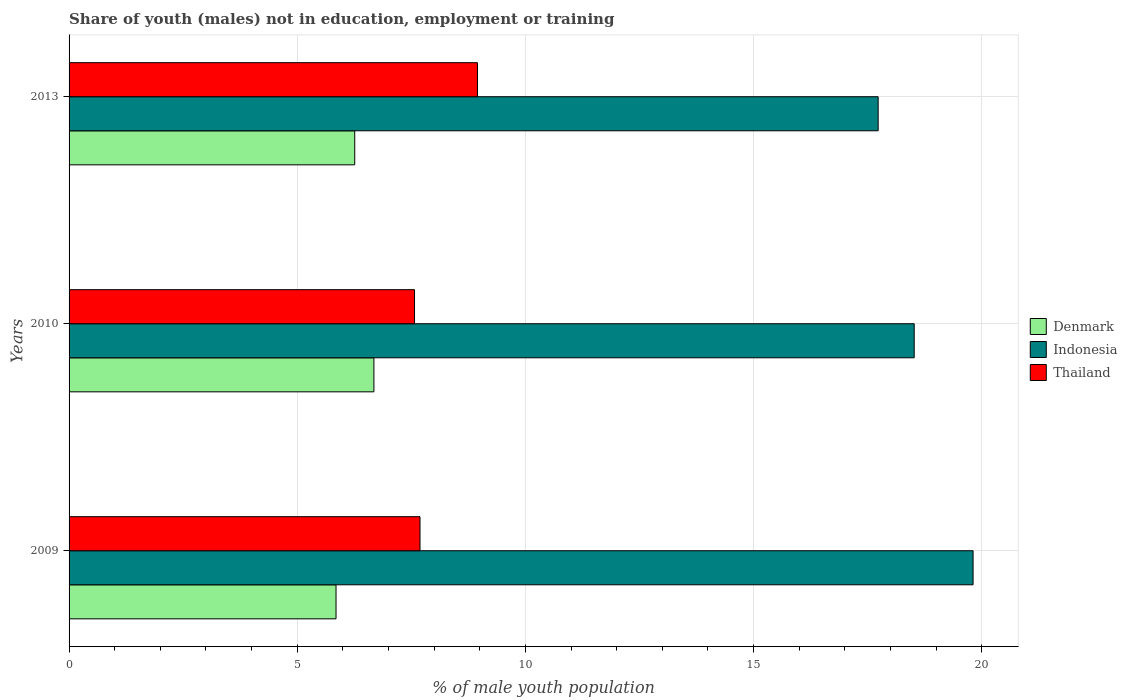How many groups of bars are there?
Keep it short and to the point. 3. Are the number of bars on each tick of the Y-axis equal?
Ensure brevity in your answer.  Yes. What is the label of the 1st group of bars from the top?
Your answer should be compact. 2013. In how many cases, is the number of bars for a given year not equal to the number of legend labels?
Your response must be concise. 0. What is the percentage of unemployed males population in in Indonesia in 2009?
Offer a very short reply. 19.81. Across all years, what is the maximum percentage of unemployed males population in in Indonesia?
Give a very brief answer. 19.81. Across all years, what is the minimum percentage of unemployed males population in in Indonesia?
Keep it short and to the point. 17.73. In which year was the percentage of unemployed males population in in Indonesia maximum?
Ensure brevity in your answer.  2009. What is the total percentage of unemployed males population in in Thailand in the graph?
Provide a short and direct response. 24.21. What is the difference between the percentage of unemployed males population in in Indonesia in 2009 and that in 2010?
Your response must be concise. 1.29. What is the difference between the percentage of unemployed males population in in Indonesia in 2010 and the percentage of unemployed males population in in Thailand in 2013?
Your answer should be very brief. 9.57. What is the average percentage of unemployed males population in in Thailand per year?
Your answer should be compact. 8.07. In the year 2013, what is the difference between the percentage of unemployed males population in in Thailand and percentage of unemployed males population in in Denmark?
Your answer should be very brief. 2.69. What is the ratio of the percentage of unemployed males population in in Indonesia in 2010 to that in 2013?
Make the answer very short. 1.04. Is the percentage of unemployed males population in in Denmark in 2010 less than that in 2013?
Make the answer very short. No. Is the difference between the percentage of unemployed males population in in Thailand in 2009 and 2010 greater than the difference between the percentage of unemployed males population in in Denmark in 2009 and 2010?
Give a very brief answer. Yes. What is the difference between the highest and the second highest percentage of unemployed males population in in Indonesia?
Provide a succinct answer. 1.29. What is the difference between the highest and the lowest percentage of unemployed males population in in Indonesia?
Make the answer very short. 2.08. Is the sum of the percentage of unemployed males population in in Indonesia in 2010 and 2013 greater than the maximum percentage of unemployed males population in in Thailand across all years?
Your answer should be compact. Yes. What does the 3rd bar from the top in 2013 represents?
Your response must be concise. Denmark. How many bars are there?
Ensure brevity in your answer.  9. How many years are there in the graph?
Offer a very short reply. 3. What is the difference between two consecutive major ticks on the X-axis?
Keep it short and to the point. 5. Does the graph contain grids?
Make the answer very short. Yes. What is the title of the graph?
Provide a short and direct response. Share of youth (males) not in education, employment or training. Does "Iran" appear as one of the legend labels in the graph?
Offer a terse response. No. What is the label or title of the X-axis?
Your answer should be compact. % of male youth population. What is the % of male youth population of Denmark in 2009?
Your response must be concise. 5.85. What is the % of male youth population of Indonesia in 2009?
Make the answer very short. 19.81. What is the % of male youth population in Thailand in 2009?
Offer a terse response. 7.69. What is the % of male youth population in Denmark in 2010?
Your answer should be very brief. 6.68. What is the % of male youth population of Indonesia in 2010?
Keep it short and to the point. 18.52. What is the % of male youth population in Thailand in 2010?
Your answer should be compact. 7.57. What is the % of male youth population in Denmark in 2013?
Provide a succinct answer. 6.26. What is the % of male youth population of Indonesia in 2013?
Offer a terse response. 17.73. What is the % of male youth population of Thailand in 2013?
Your answer should be compact. 8.95. Across all years, what is the maximum % of male youth population of Denmark?
Keep it short and to the point. 6.68. Across all years, what is the maximum % of male youth population of Indonesia?
Offer a very short reply. 19.81. Across all years, what is the maximum % of male youth population in Thailand?
Provide a short and direct response. 8.95. Across all years, what is the minimum % of male youth population of Denmark?
Offer a very short reply. 5.85. Across all years, what is the minimum % of male youth population in Indonesia?
Offer a very short reply. 17.73. Across all years, what is the minimum % of male youth population in Thailand?
Provide a succinct answer. 7.57. What is the total % of male youth population in Denmark in the graph?
Your answer should be compact. 18.79. What is the total % of male youth population of Indonesia in the graph?
Provide a short and direct response. 56.06. What is the total % of male youth population in Thailand in the graph?
Keep it short and to the point. 24.21. What is the difference between the % of male youth population in Denmark in 2009 and that in 2010?
Your response must be concise. -0.83. What is the difference between the % of male youth population in Indonesia in 2009 and that in 2010?
Keep it short and to the point. 1.29. What is the difference between the % of male youth population in Thailand in 2009 and that in 2010?
Ensure brevity in your answer.  0.12. What is the difference between the % of male youth population in Denmark in 2009 and that in 2013?
Offer a terse response. -0.41. What is the difference between the % of male youth population in Indonesia in 2009 and that in 2013?
Offer a very short reply. 2.08. What is the difference between the % of male youth population of Thailand in 2009 and that in 2013?
Your answer should be very brief. -1.26. What is the difference between the % of male youth population in Denmark in 2010 and that in 2013?
Your answer should be compact. 0.42. What is the difference between the % of male youth population of Indonesia in 2010 and that in 2013?
Make the answer very short. 0.79. What is the difference between the % of male youth population of Thailand in 2010 and that in 2013?
Give a very brief answer. -1.38. What is the difference between the % of male youth population of Denmark in 2009 and the % of male youth population of Indonesia in 2010?
Provide a short and direct response. -12.67. What is the difference between the % of male youth population of Denmark in 2009 and the % of male youth population of Thailand in 2010?
Ensure brevity in your answer.  -1.72. What is the difference between the % of male youth population of Indonesia in 2009 and the % of male youth population of Thailand in 2010?
Your answer should be compact. 12.24. What is the difference between the % of male youth population of Denmark in 2009 and the % of male youth population of Indonesia in 2013?
Offer a very short reply. -11.88. What is the difference between the % of male youth population in Indonesia in 2009 and the % of male youth population in Thailand in 2013?
Your answer should be compact. 10.86. What is the difference between the % of male youth population in Denmark in 2010 and the % of male youth population in Indonesia in 2013?
Give a very brief answer. -11.05. What is the difference between the % of male youth population in Denmark in 2010 and the % of male youth population in Thailand in 2013?
Keep it short and to the point. -2.27. What is the difference between the % of male youth population in Indonesia in 2010 and the % of male youth population in Thailand in 2013?
Offer a terse response. 9.57. What is the average % of male youth population of Denmark per year?
Give a very brief answer. 6.26. What is the average % of male youth population in Indonesia per year?
Ensure brevity in your answer.  18.69. What is the average % of male youth population in Thailand per year?
Provide a short and direct response. 8.07. In the year 2009, what is the difference between the % of male youth population in Denmark and % of male youth population in Indonesia?
Provide a succinct answer. -13.96. In the year 2009, what is the difference between the % of male youth population in Denmark and % of male youth population in Thailand?
Your answer should be compact. -1.84. In the year 2009, what is the difference between the % of male youth population in Indonesia and % of male youth population in Thailand?
Your answer should be very brief. 12.12. In the year 2010, what is the difference between the % of male youth population in Denmark and % of male youth population in Indonesia?
Your answer should be compact. -11.84. In the year 2010, what is the difference between the % of male youth population in Denmark and % of male youth population in Thailand?
Your answer should be compact. -0.89. In the year 2010, what is the difference between the % of male youth population in Indonesia and % of male youth population in Thailand?
Your answer should be very brief. 10.95. In the year 2013, what is the difference between the % of male youth population in Denmark and % of male youth population in Indonesia?
Offer a very short reply. -11.47. In the year 2013, what is the difference between the % of male youth population in Denmark and % of male youth population in Thailand?
Make the answer very short. -2.69. In the year 2013, what is the difference between the % of male youth population of Indonesia and % of male youth population of Thailand?
Provide a short and direct response. 8.78. What is the ratio of the % of male youth population in Denmark in 2009 to that in 2010?
Offer a terse response. 0.88. What is the ratio of the % of male youth population in Indonesia in 2009 to that in 2010?
Offer a terse response. 1.07. What is the ratio of the % of male youth population of Thailand in 2009 to that in 2010?
Offer a very short reply. 1.02. What is the ratio of the % of male youth population of Denmark in 2009 to that in 2013?
Give a very brief answer. 0.93. What is the ratio of the % of male youth population of Indonesia in 2009 to that in 2013?
Offer a very short reply. 1.12. What is the ratio of the % of male youth population in Thailand in 2009 to that in 2013?
Your answer should be compact. 0.86. What is the ratio of the % of male youth population of Denmark in 2010 to that in 2013?
Keep it short and to the point. 1.07. What is the ratio of the % of male youth population in Indonesia in 2010 to that in 2013?
Your answer should be very brief. 1.04. What is the ratio of the % of male youth population of Thailand in 2010 to that in 2013?
Your answer should be compact. 0.85. What is the difference between the highest and the second highest % of male youth population in Denmark?
Provide a short and direct response. 0.42. What is the difference between the highest and the second highest % of male youth population in Indonesia?
Provide a succinct answer. 1.29. What is the difference between the highest and the second highest % of male youth population in Thailand?
Offer a terse response. 1.26. What is the difference between the highest and the lowest % of male youth population of Denmark?
Make the answer very short. 0.83. What is the difference between the highest and the lowest % of male youth population in Indonesia?
Make the answer very short. 2.08. What is the difference between the highest and the lowest % of male youth population in Thailand?
Your response must be concise. 1.38. 